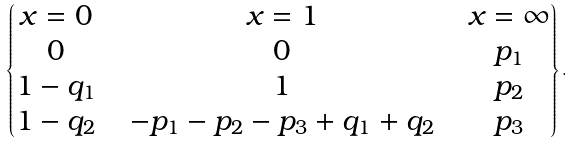<formula> <loc_0><loc_0><loc_500><loc_500>\begin{Bmatrix} x = 0 & & x = 1 & & x = \infty \\ 0 & & 0 & & p _ { 1 } \\ 1 - q _ { 1 } & & 1 & & p _ { 2 } \\ 1 - q _ { 2 } & & - p _ { 1 } - p _ { 2 } - p _ { 3 } + q _ { 1 } + q _ { 2 } & & p _ { 3 } \end{Bmatrix} .</formula> 